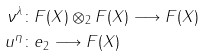Convert formula to latex. <formula><loc_0><loc_0><loc_500><loc_500>\nu ^ { \lambda } & \colon F ( X ) \otimes _ { 2 } F ( X ) \longrightarrow F ( X ) \\ u ^ { \eta } & \colon e _ { 2 } \longrightarrow F ( X )</formula> 